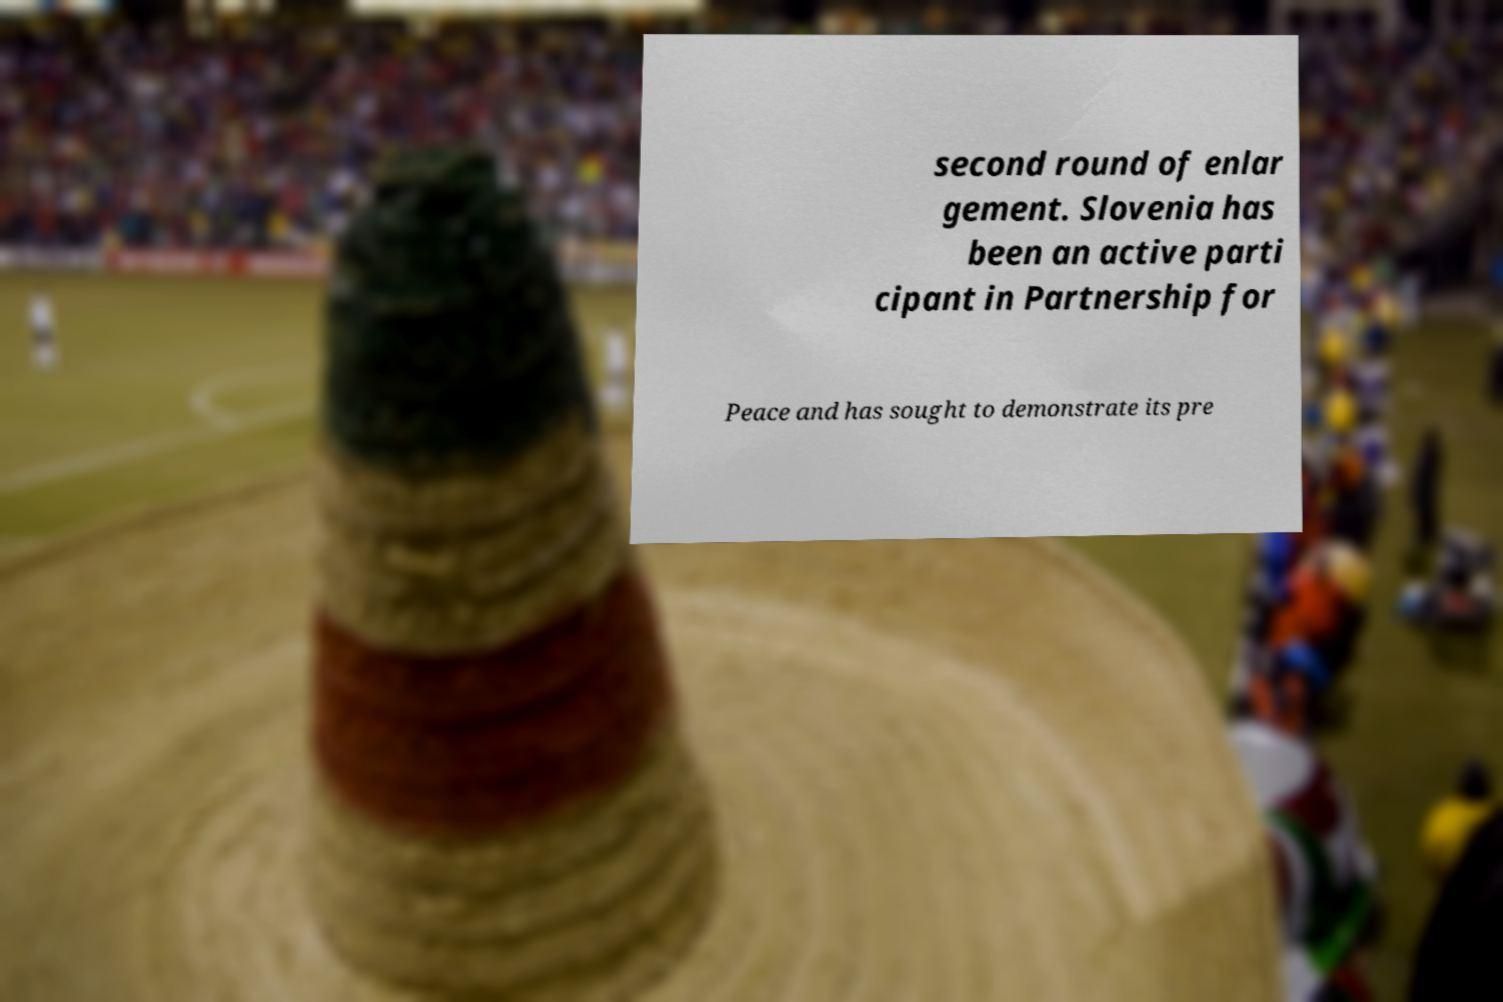There's text embedded in this image that I need extracted. Can you transcribe it verbatim? second round of enlar gement. Slovenia has been an active parti cipant in Partnership for Peace and has sought to demonstrate its pre 